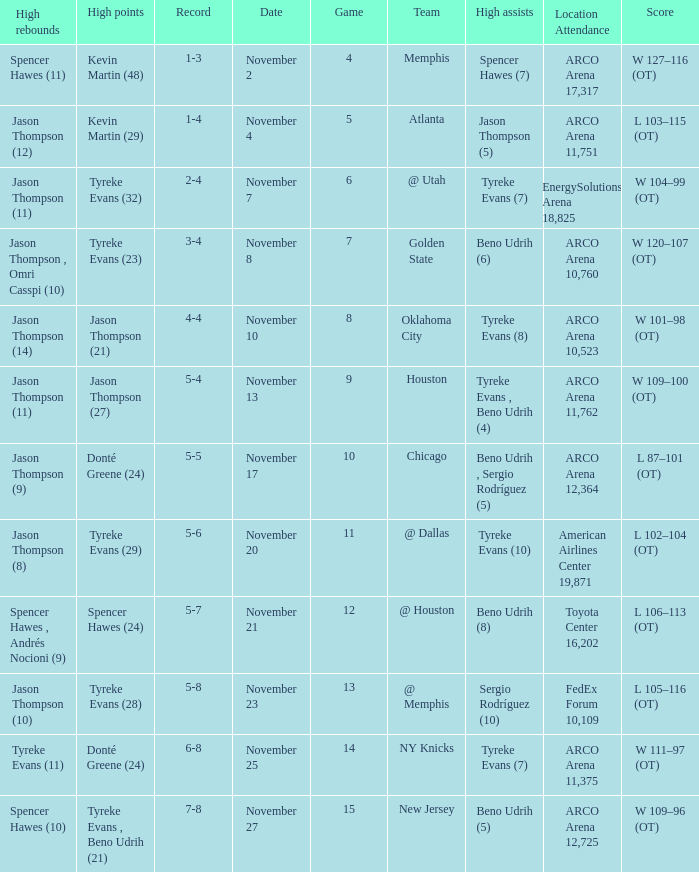If the record is 6-8, what was the score? W 111–97 (OT). 